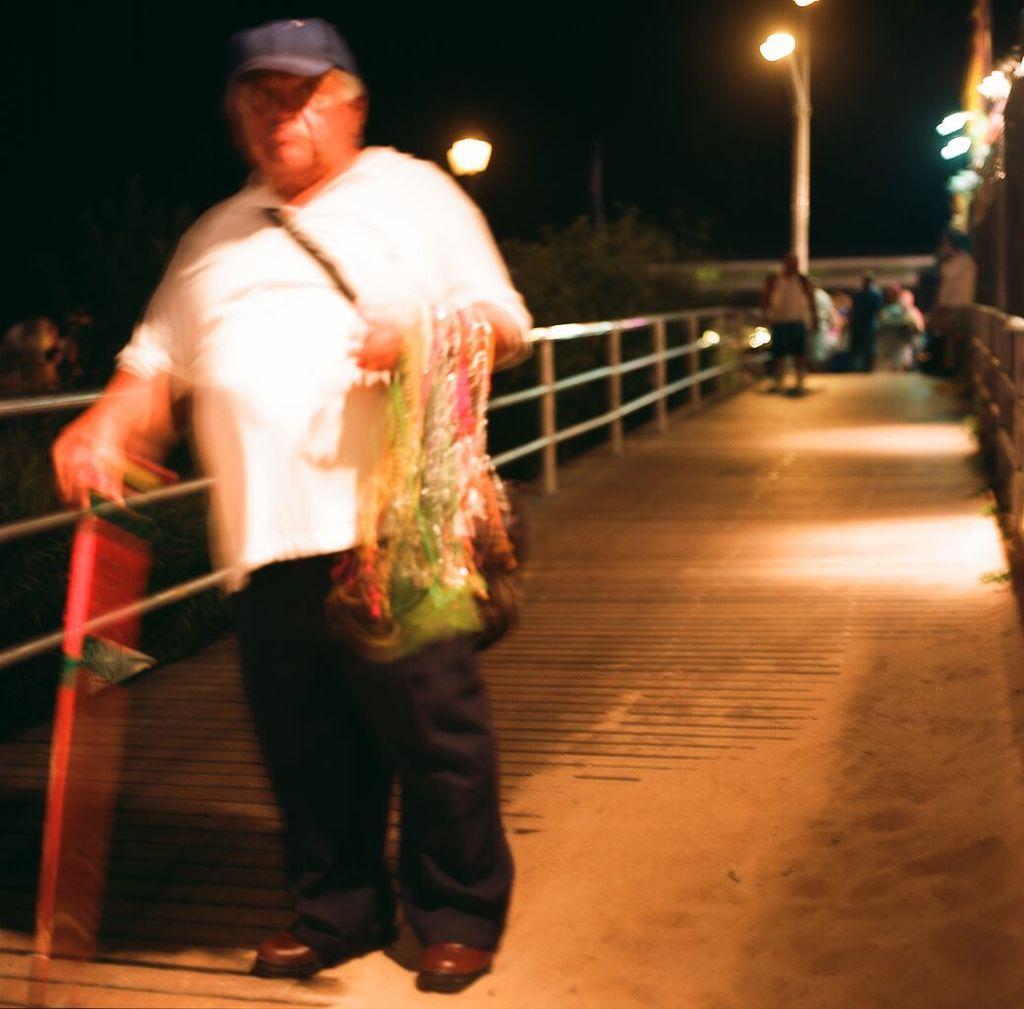Describe this image in one or two sentences. In this picture there is a man on the left side of the image and there are other people on the right side of the image, there is a pole at the top side of the image. 